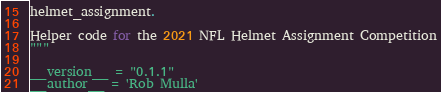Convert code to text. <code><loc_0><loc_0><loc_500><loc_500><_Python_>helmet_assignment.

Helper code for the 2021 NFL Helmet Assignment Competition
"""

__version__ = "0.1.1"
__author__ = 'Rob Mulla'
</code> 